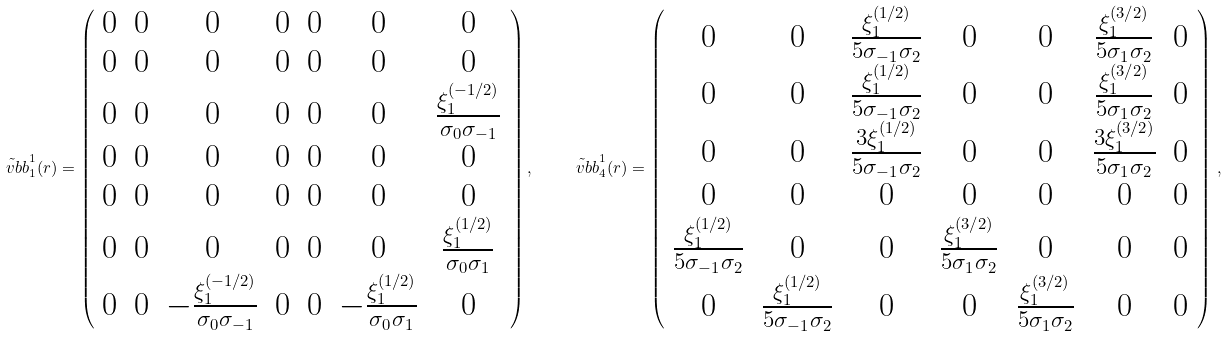Convert formula to latex. <formula><loc_0><loc_0><loc_500><loc_500>\tilde { \ v b b } _ { 1 } ^ { 1 } ( r ) = \left ( \begin{array} { c c c c c c c } 0 & 0 & 0 & 0 & 0 & 0 & 0 \\ 0 & 0 & 0 & 0 & 0 & 0 & 0 \\ 0 & 0 & 0 & 0 & 0 & 0 & \frac { \xi _ { 1 } ^ { ( - 1 / 2 ) } } { \sigma _ { 0 } \sigma _ { - 1 } } \\ 0 & 0 & 0 & 0 & 0 & 0 & 0 \\ 0 & 0 & 0 & 0 & 0 & 0 & 0 \\ 0 & 0 & 0 & 0 & 0 & 0 & \frac { \xi _ { 1 } ^ { ( 1 / 2 ) } } { \sigma _ { 0 } \sigma _ { 1 } } \\ 0 & 0 & - \frac { \xi _ { 1 } ^ { ( - 1 / 2 ) } } { \sigma _ { 0 } \sigma _ { - 1 } } & 0 & 0 & - \frac { \xi _ { 1 } ^ { ( 1 / 2 ) } } { \sigma _ { 0 } \sigma _ { 1 } } & 0 \end{array} \right ) , \quad \tilde { \ v b b } _ { 4 } ^ { 1 } ( r ) = \left ( \begin{array} { c c c c c c c } 0 & 0 & \frac { \xi _ { 1 } ^ { ( 1 / 2 ) } } { 5 \sigma _ { - 1 } \sigma _ { 2 } } & 0 & 0 & \frac { \xi _ { 1 } ^ { ( 3 / 2 ) } } { 5 \sigma _ { 1 } \sigma _ { 2 } } & 0 \\ 0 & 0 & \frac { \xi _ { 1 } ^ { ( 1 / 2 ) } } { 5 \sigma _ { - 1 } \sigma _ { 2 } } & 0 & 0 & \frac { \xi _ { 1 } ^ { ( 3 / 2 ) } } { 5 \sigma _ { 1 } \sigma _ { 2 } } & 0 \\ 0 & 0 & \frac { 3 \xi _ { 1 } ^ { ( 1 / 2 ) } } { 5 \sigma _ { - 1 } \sigma _ { 2 } } & 0 & 0 & \frac { 3 \xi _ { 1 } ^ { ( 3 / 2 ) } } { 5 \sigma _ { 1 } \sigma _ { 2 } } & 0 \\ 0 & 0 & 0 & 0 & 0 & 0 & 0 \\ \frac { \xi _ { 1 } ^ { ( 1 / 2 ) } } { 5 \sigma _ { - 1 } \sigma _ { 2 } } & 0 & 0 & \frac { \xi _ { 1 } ^ { ( 3 / 2 ) } } { 5 \sigma _ { 1 } \sigma _ { 2 } } & 0 & 0 & 0 \\ 0 & \frac { \xi _ { 1 } ^ { ( 1 / 2 ) } } { 5 \sigma _ { - 1 } \sigma _ { 2 } } & 0 & 0 & \frac { \xi _ { 1 } ^ { ( 3 / 2 ) } } { 5 \sigma _ { 1 } \sigma _ { 2 } } & 0 & 0 \end{array} \right ) \, ,</formula> 